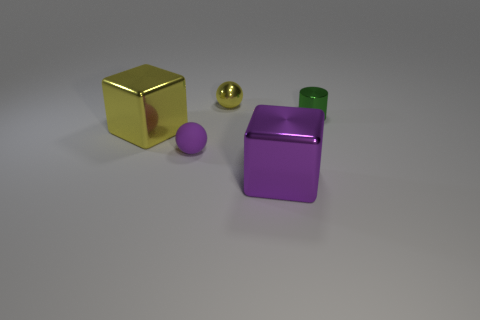Are there any other things that are the same material as the small purple object?
Give a very brief answer. No. What number of green things are small cylinders or tiny spheres?
Make the answer very short. 1. Are there any green things of the same size as the yellow ball?
Your response must be concise. Yes. There is a small ball in front of the big block to the left of the yellow object behind the small cylinder; what is it made of?
Offer a terse response. Rubber. Are there an equal number of big yellow metallic blocks on the left side of the purple shiny thing and cyan spheres?
Provide a short and direct response. No. Is the material of the yellow thing in front of the small shiny cylinder the same as the object that is on the right side of the big purple block?
Provide a succinct answer. Yes. What number of things are either rubber cylinders or metallic cubes to the left of the big purple metal object?
Offer a very short reply. 1. Is there a purple object that has the same shape as the big yellow thing?
Provide a succinct answer. Yes. There is a yellow object behind the big metal cube behind the large purple metallic block in front of the small green cylinder; what is its size?
Make the answer very short. Small. Is the number of yellow blocks behind the rubber sphere the same as the number of purple matte objects behind the shiny sphere?
Keep it short and to the point. No. 